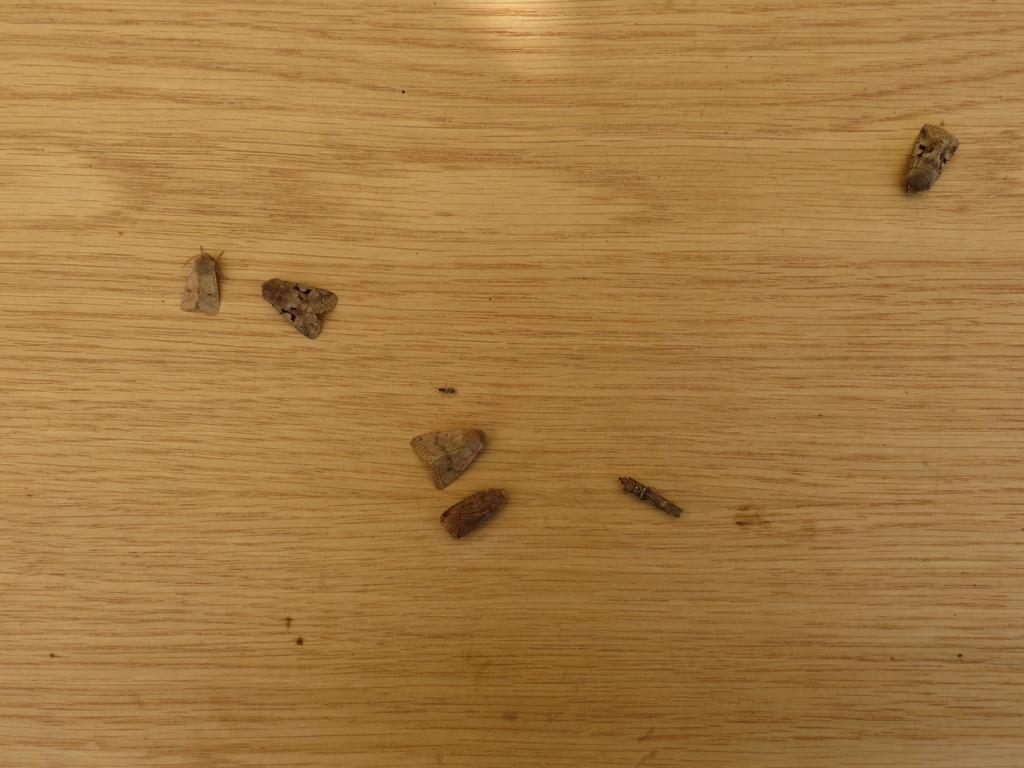What type of creatures can be seen on the table in the image? There are insects on the table in the image. How does the kettle help the insects during the rainstorm in the image? There is no kettle or rainstorm present in the image; it only features insects on the table. 